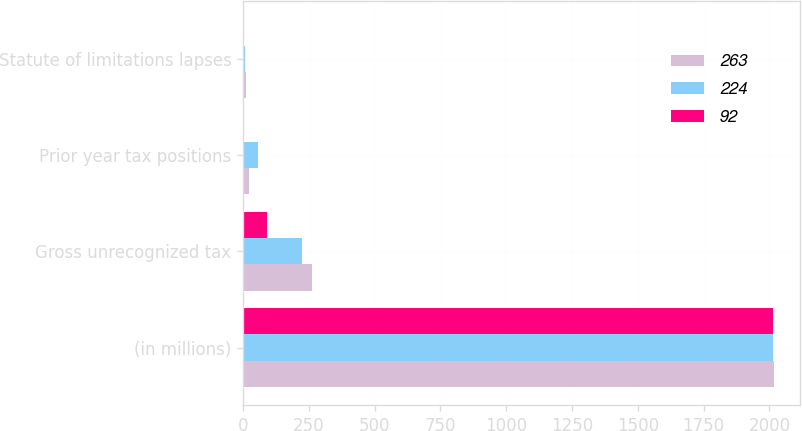Convert chart to OTSL. <chart><loc_0><loc_0><loc_500><loc_500><stacked_bar_chart><ecel><fcel>(in millions)<fcel>Gross unrecognized tax<fcel>Prior year tax positions<fcel>Statute of limitations lapses<nl><fcel>263<fcel>2016<fcel>263<fcel>24<fcel>12<nl><fcel>224<fcel>2015<fcel>224<fcel>55<fcel>9<nl><fcel>92<fcel>2014<fcel>92<fcel>4<fcel>1<nl></chart> 